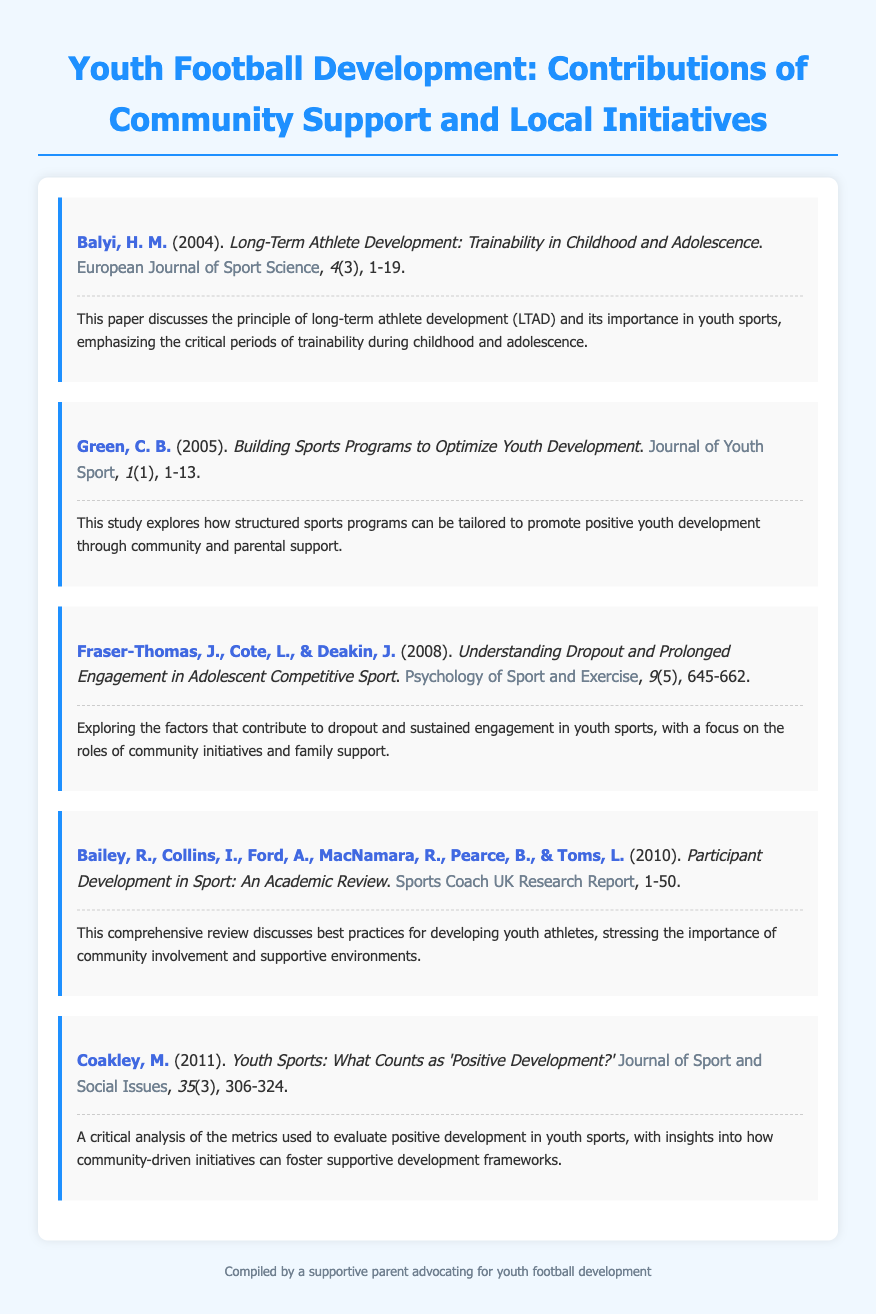what is the title of the first entry? The title is "Long-Term Athlete Development: Trainability in Childhood and Adolescence."
Answer: Long-Term Athlete Development: Trainability in Childhood and Adolescence who is the author of the second entry? The author is C. B. Green.
Answer: C. B. Green what is the year of publication for the last entry? The year of publication for the last entry is 2011.
Answer: 2011 how many authors contributed to the fourth entry? The entry lists six authors who contributed to it.
Answer: six what is the main focus of Fraser-Thomas et al.'s paper? The focus is on dropout and prolonged engagement in adolescent competitive sport.
Answer: dropout and prolonged engagement in adolescent competitive sport which journal published the entry by Bailey et al.? The entry was published in the Sports Coach UK Research Report.
Answer: Sports Coach UK Research Report what is emphasized in Balyi's paper? The paper emphasizes the critical periods of trainability during childhood and adolescence.
Answer: critical periods of trainability during childhood and adolescence what is the theme addressed in Coakley's paper? The theme is the evaluation of positive development in youth sports.
Answer: evaluation of positive development in youth sports 